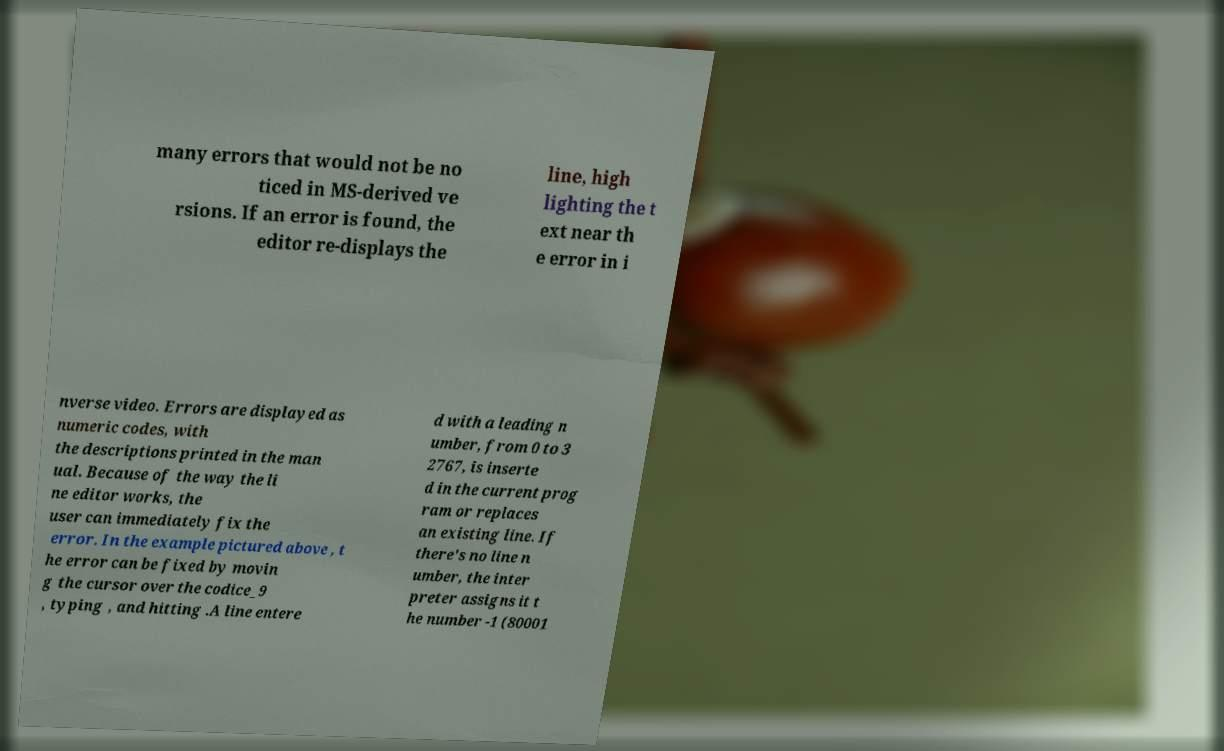What messages or text are displayed in this image? I need them in a readable, typed format. many errors that would not be no ticed in MS-derived ve rsions. If an error is found, the editor re-displays the line, high lighting the t ext near th e error in i nverse video. Errors are displayed as numeric codes, with the descriptions printed in the man ual. Because of the way the li ne editor works, the user can immediately fix the error. In the example pictured above , t he error can be fixed by movin g the cursor over the codice_9 , typing , and hitting .A line entere d with a leading n umber, from 0 to 3 2767, is inserte d in the current prog ram or replaces an existing line. If there's no line n umber, the inter preter assigns it t he number -1 (80001 